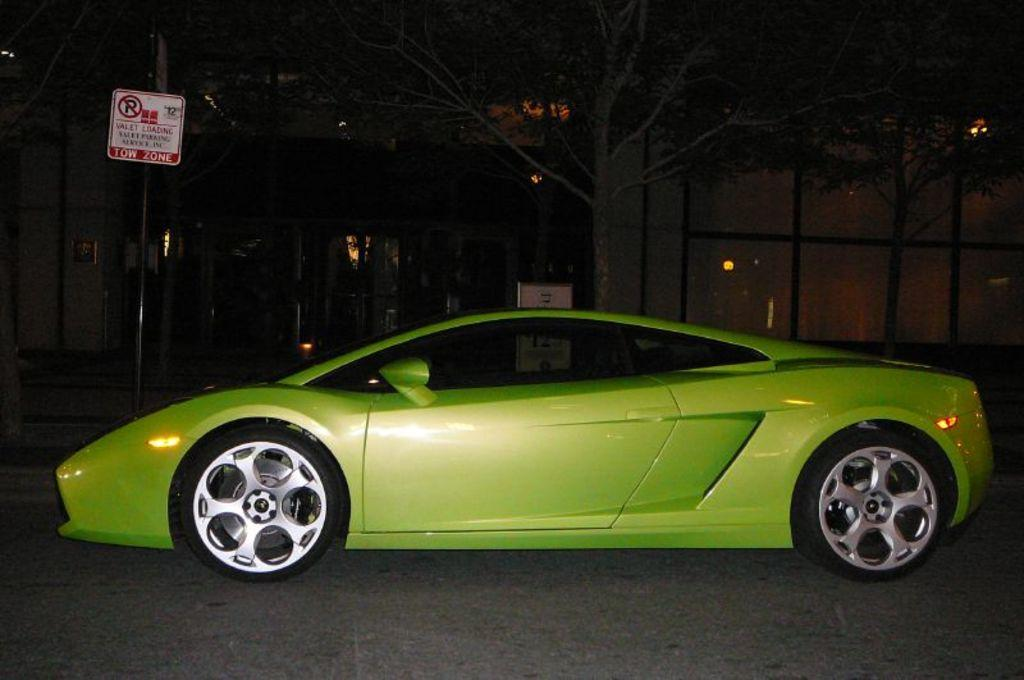What is the main subject of the image? There is a car in the image. What can be seen in the background of the image? There are trees in the background of the image. What type of structure is present in the image? There is a building in the image. What is attached to the pole in the image? There is a pole with a sign board in the image. How many oranges are hanging from the tree in the image? There are no oranges present in the image; only trees can be seen in the background. 